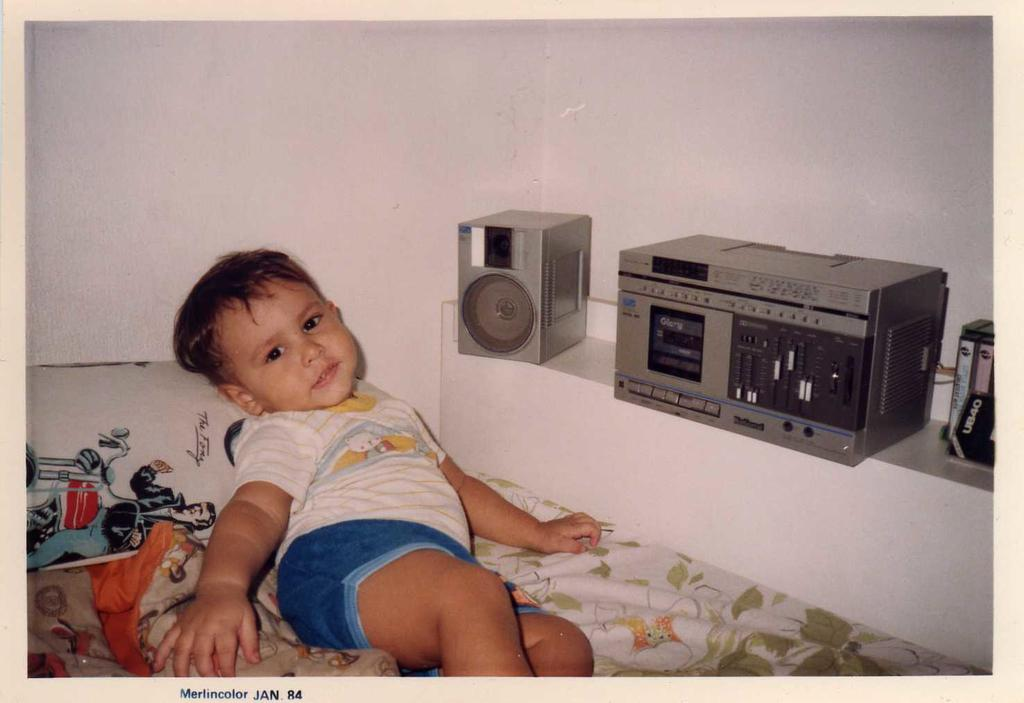What is the kid doing in the image? The kid is lying on the bed in the image. What can be seen on the right side of the image? There is a music player on the right side of the image. Where is the speaker located in the image? The speaker is on the shelf in the image. What type of goat can be seen playing with the music player in the image? There is no goat present in the image; the music player is on the right side of the bed where the kid is lying. 